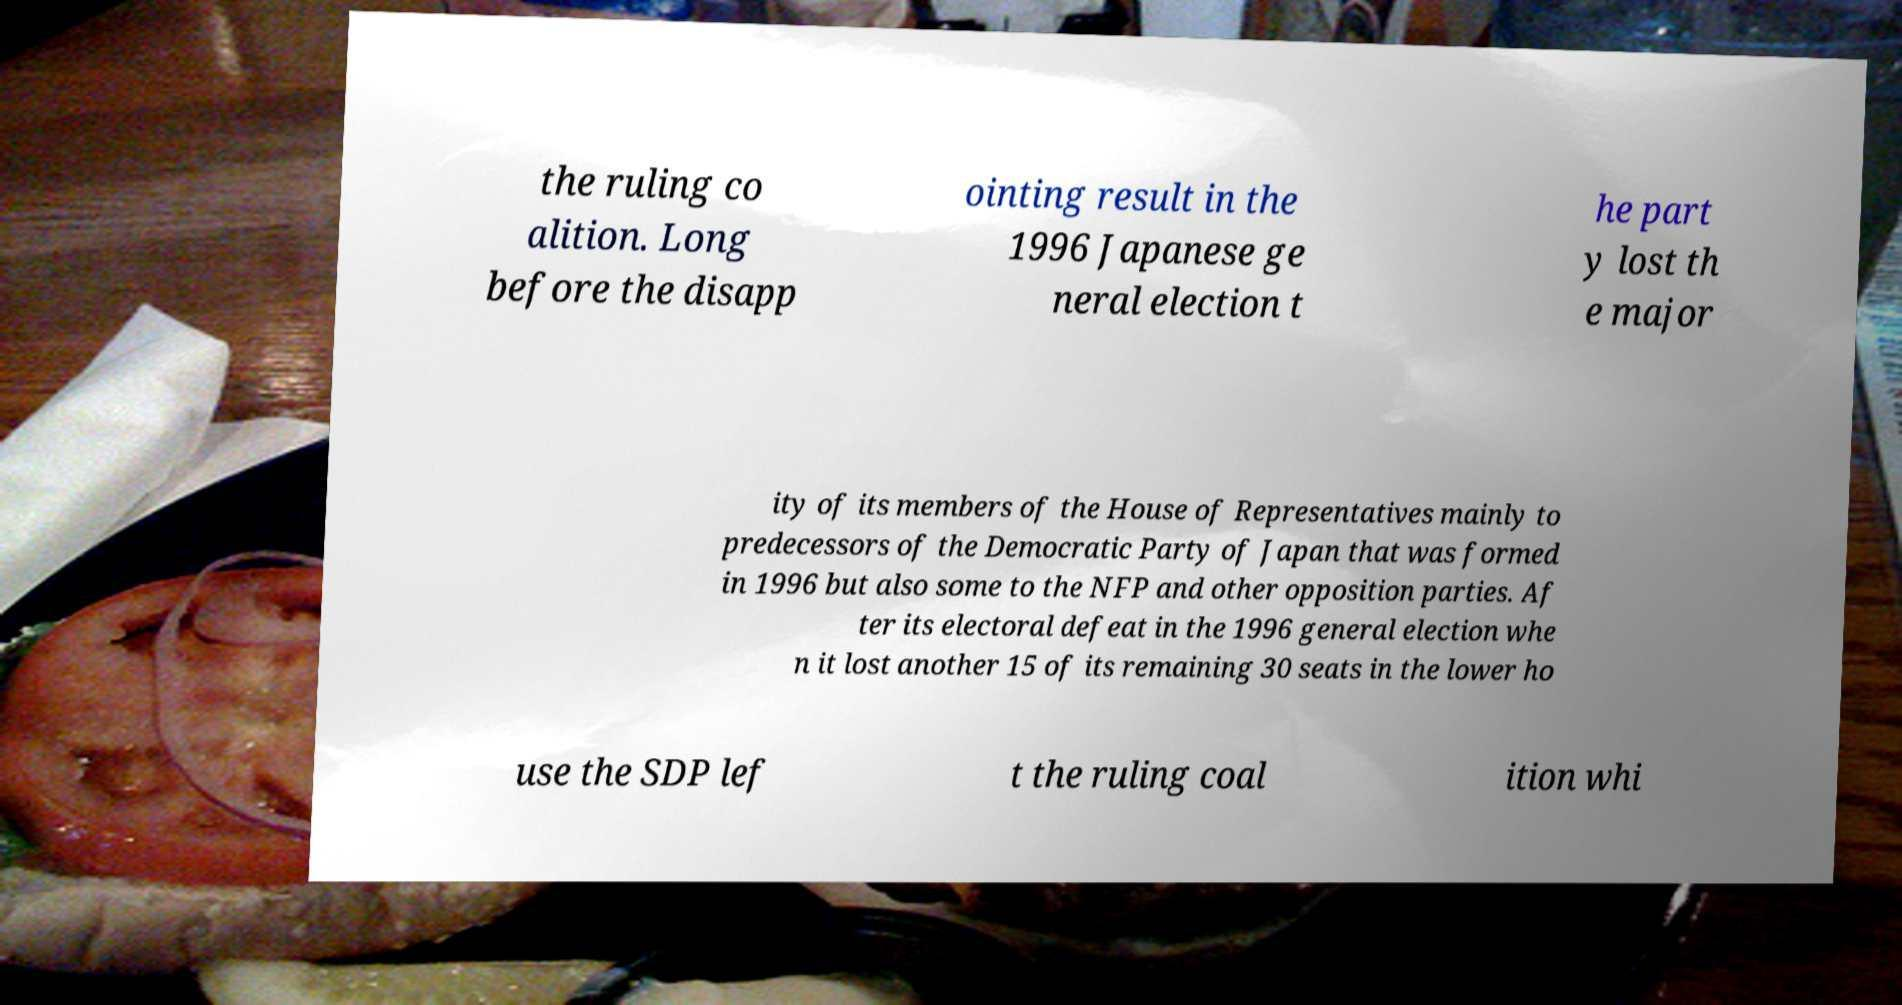Please read and relay the text visible in this image. What does it say? the ruling co alition. Long before the disapp ointing result in the 1996 Japanese ge neral election t he part y lost th e major ity of its members of the House of Representatives mainly to predecessors of the Democratic Party of Japan that was formed in 1996 but also some to the NFP and other opposition parties. Af ter its electoral defeat in the 1996 general election whe n it lost another 15 of its remaining 30 seats in the lower ho use the SDP lef t the ruling coal ition whi 